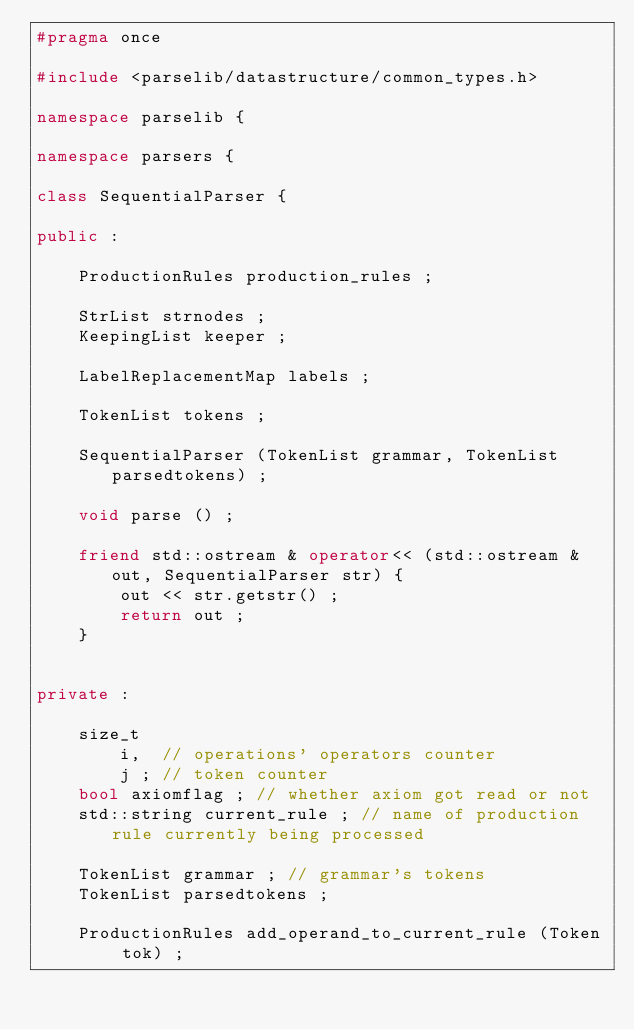Convert code to text. <code><loc_0><loc_0><loc_500><loc_500><_C++_>#pragma once

#include <parselib/datastructure/common_types.h>

namespace parselib {

namespace parsers {

class SequentialParser {

public :

	ProductionRules production_rules ;
	
	StrList strnodes ;
	KeepingList keeper ;
	
	LabelReplacementMap labels ;
	
	TokenList tokens ;

	SequentialParser (TokenList grammar, TokenList parsedtokens) ;

	void parse () ;

	friend std::ostream & operator<< (std::ostream & out, SequentialParser str) {
		out << str.getstr() ;
		return out ;
	}


private :

	size_t
		i,  // operations' operators counter
		j ; // token counter
	bool axiomflag ; // whether axiom got read or not
	std::string current_rule ; // name of production rule currently being processed
	
	TokenList grammar ; // grammar's tokens
	TokenList parsedtokens ;
	
	ProductionRules add_operand_to_current_rule (Token tok) ;
</code> 